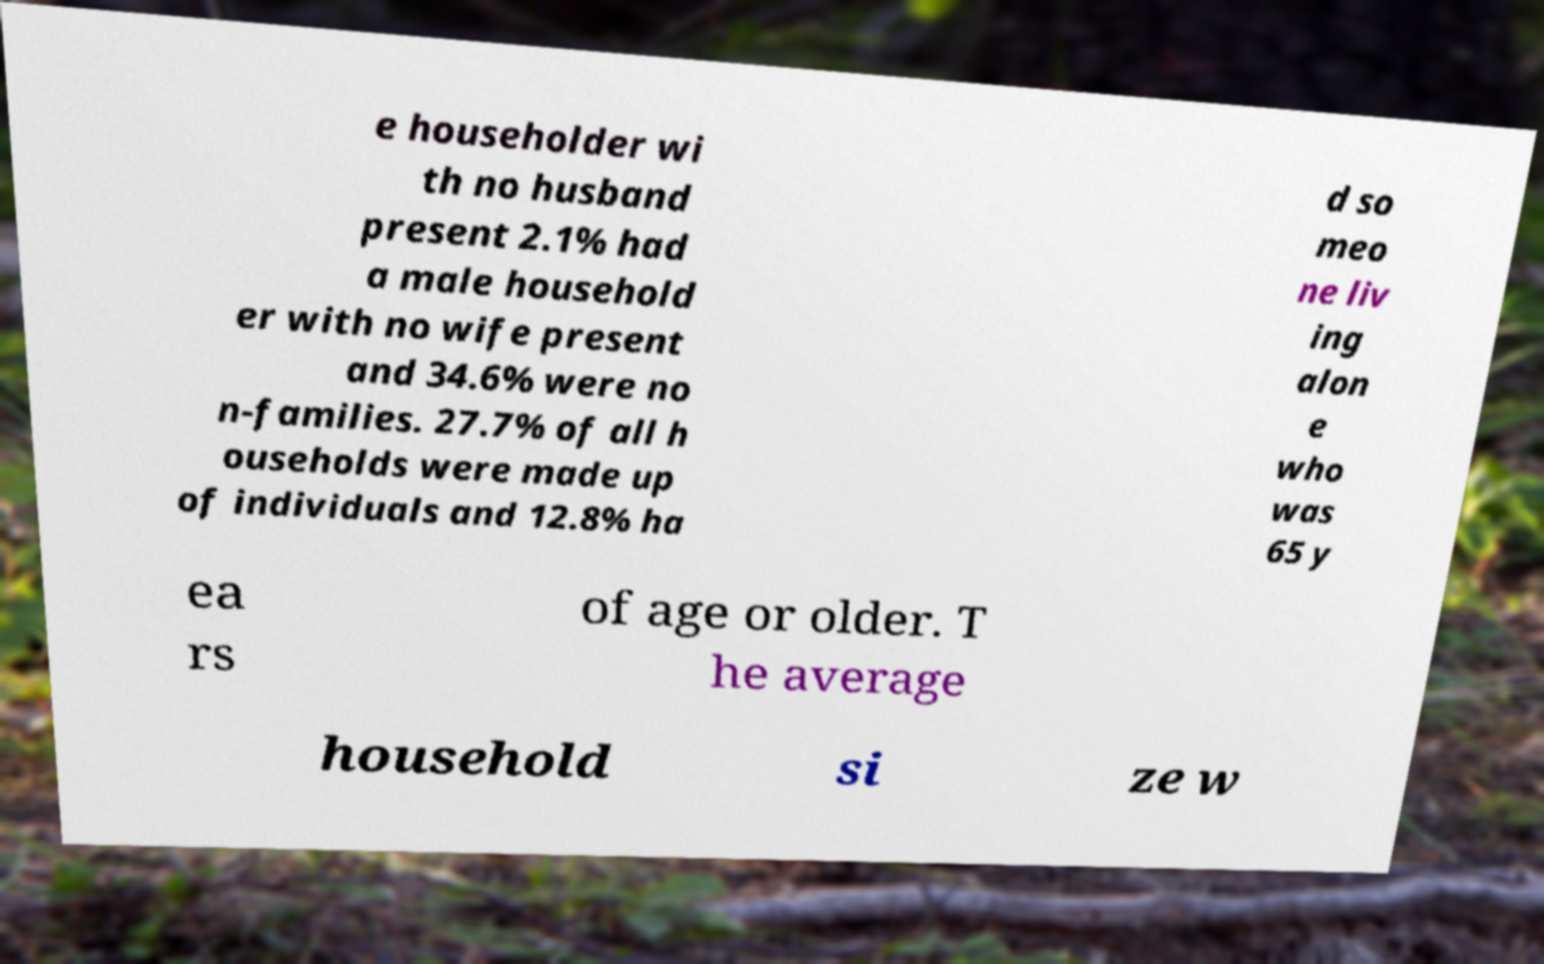Please identify and transcribe the text found in this image. e householder wi th no husband present 2.1% had a male household er with no wife present and 34.6% were no n-families. 27.7% of all h ouseholds were made up of individuals and 12.8% ha d so meo ne liv ing alon e who was 65 y ea rs of age or older. T he average household si ze w 